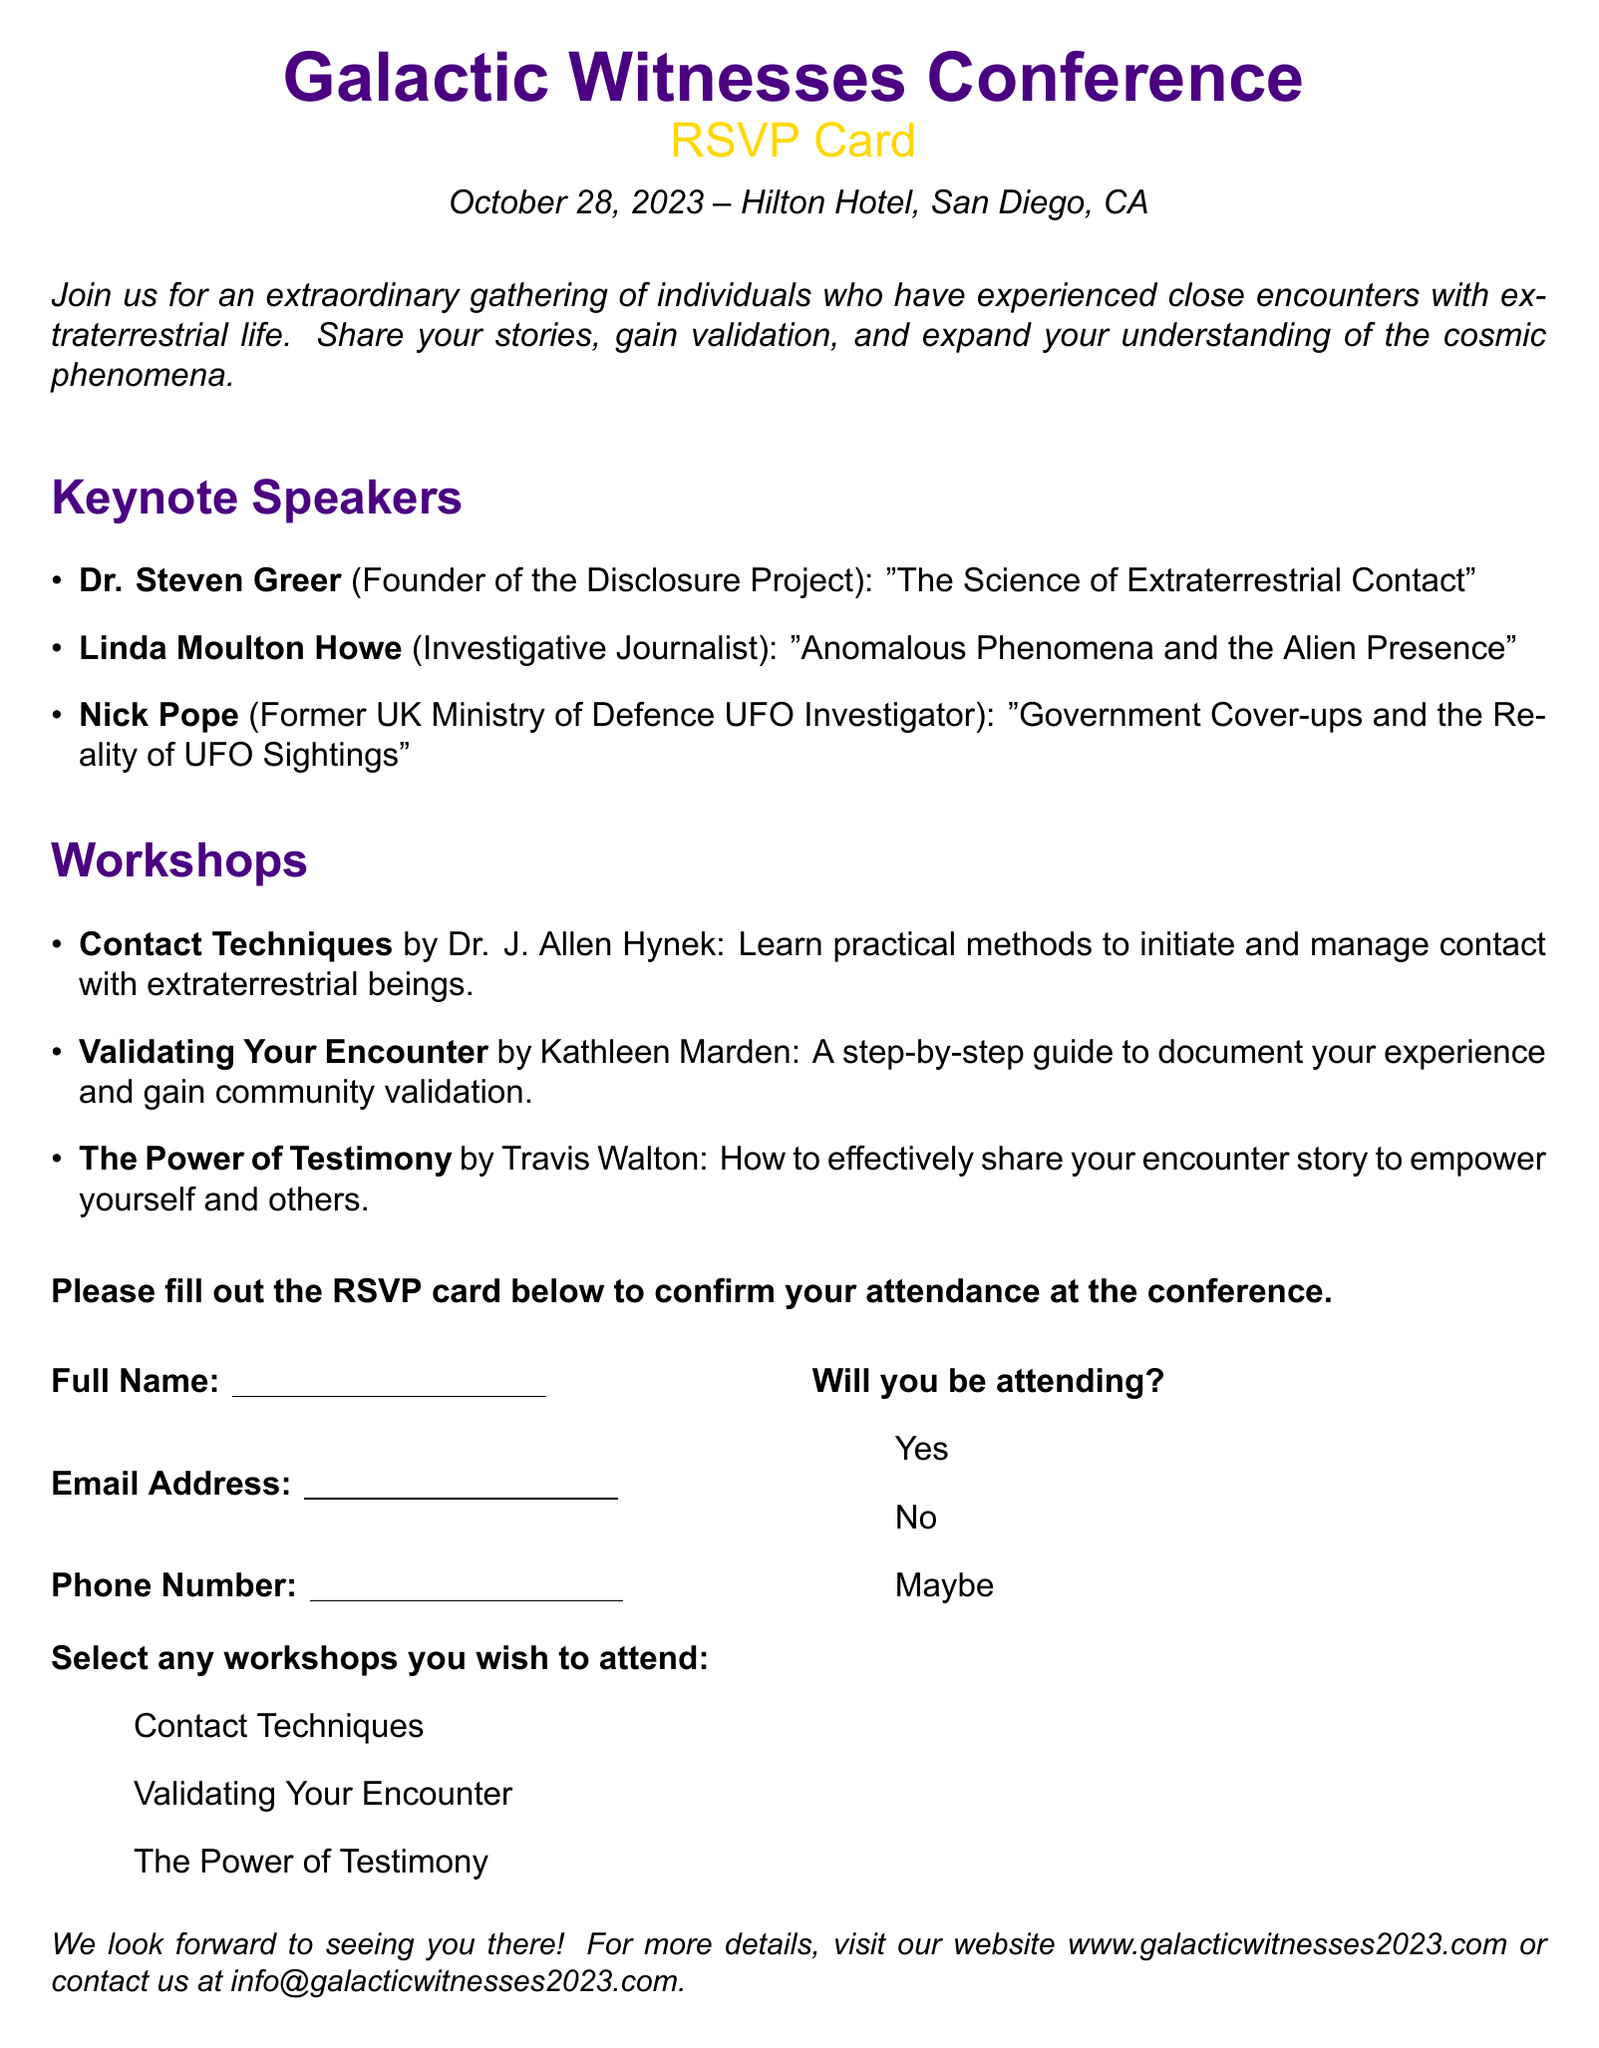What is the date of the conference? The document states the conference will take place on October 28, 2023.
Answer: October 28, 2023 Who is the founder of the Disclosure Project? The document mentions Dr. Steven Greer as the founder of the Disclosure Project.
Answer: Dr. Steven Greer Which hotel will host the conference? According to the document, the conference will be held at the Hilton Hotel, San Diego, CA.
Answer: Hilton Hotel, San Diego, CA What is the title of Linda Moulton Howe's keynote speech? The document lists Linda Moulton Howe's keynote speech as "Anomalous Phenomena and the Alien Presence."
Answer: Anomalous Phenomena and the Alien Presence How many workshops can attendees select? The document states there are three workshops available for selection.
Answer: Three What is the purpose of the conference? The document explains that the conference is an extraordinary gathering of individuals who have experienced close encounters with extraterrestrial life.
Answer: To share stories and gain validation Which workshop is led by Kathleen Marden? The document indicates that Kathleen Marden leads the workshop titled "Validating Your Encounter."
Answer: Validating Your Encounter What is needed to confirm attendance? The document states that filling out the RSVP card is required to confirm attendance.
Answer: RSVP card 